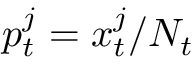<formula> <loc_0><loc_0><loc_500><loc_500>p _ { t } ^ { j } = x _ { t } ^ { j } / N _ { t }</formula> 